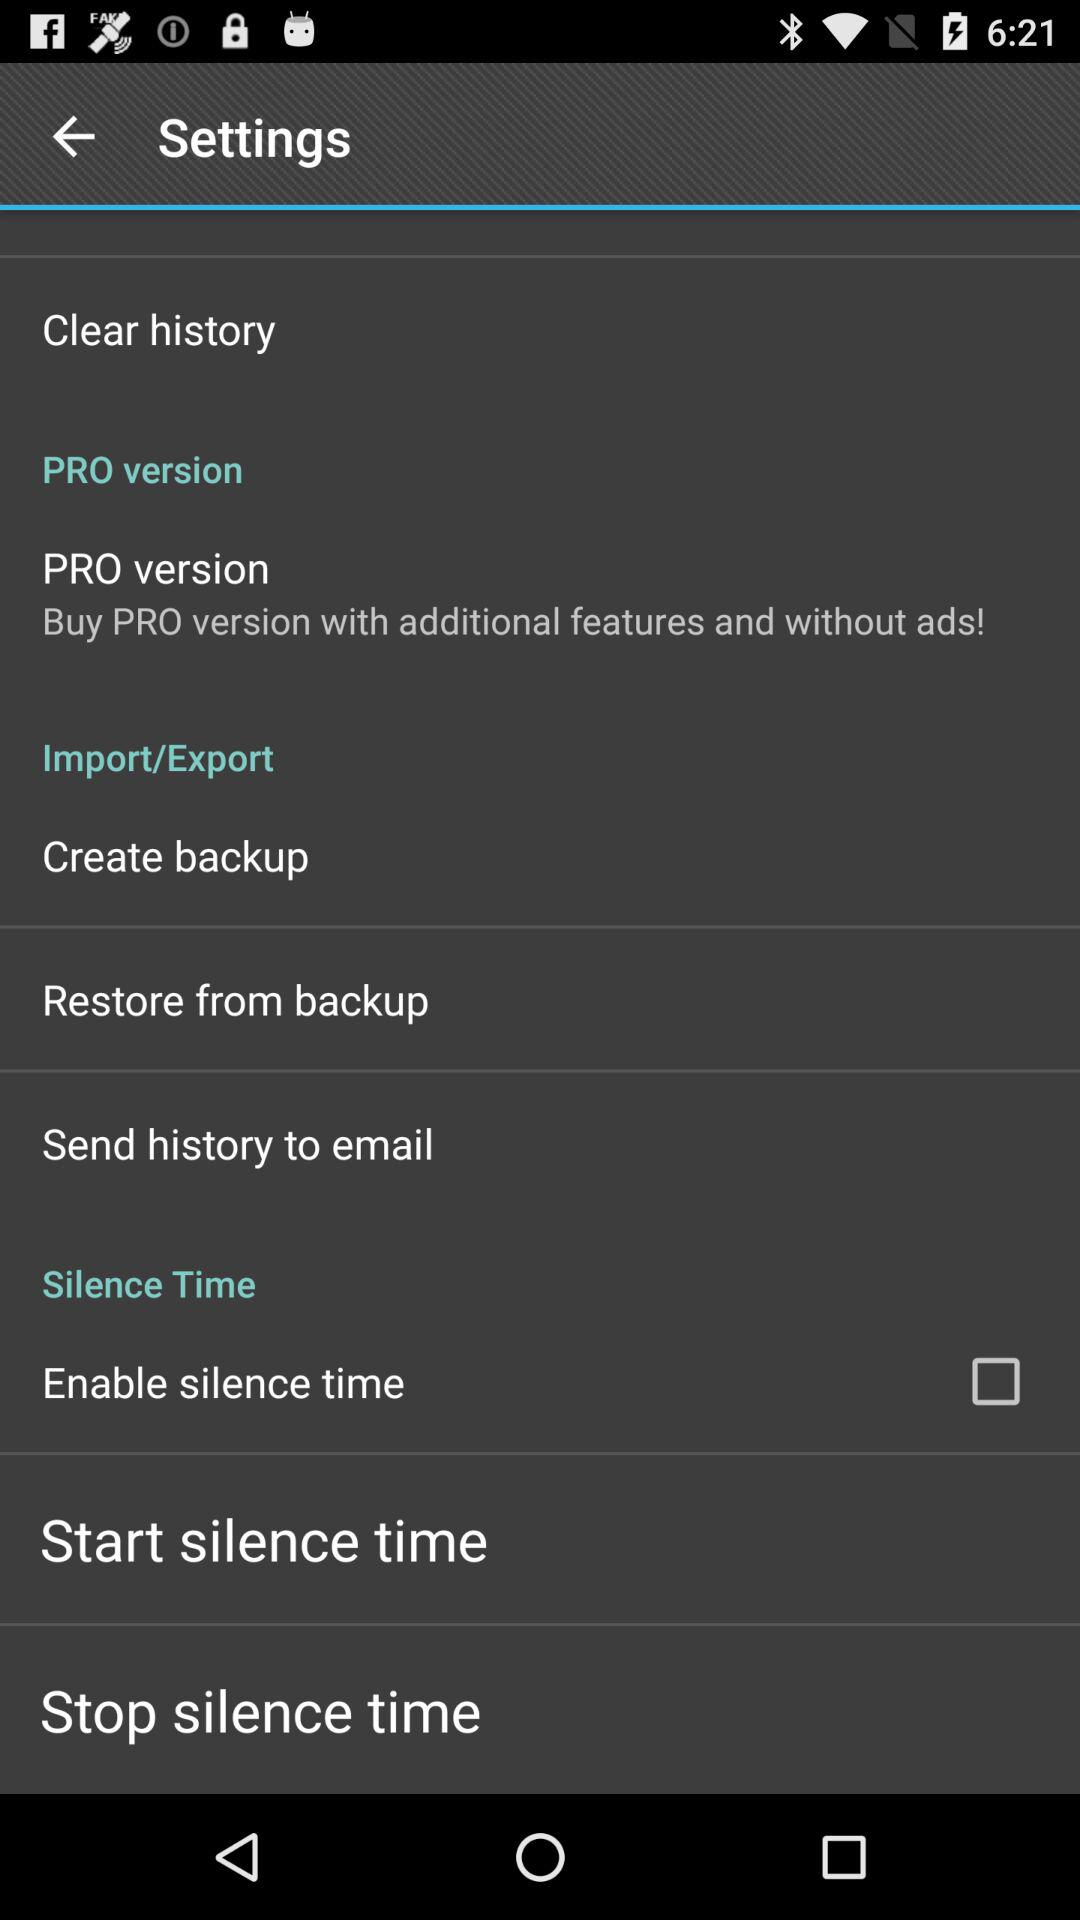What version should we buy for additional features and without ads? You should buy the pro version for additional features and without ads. 